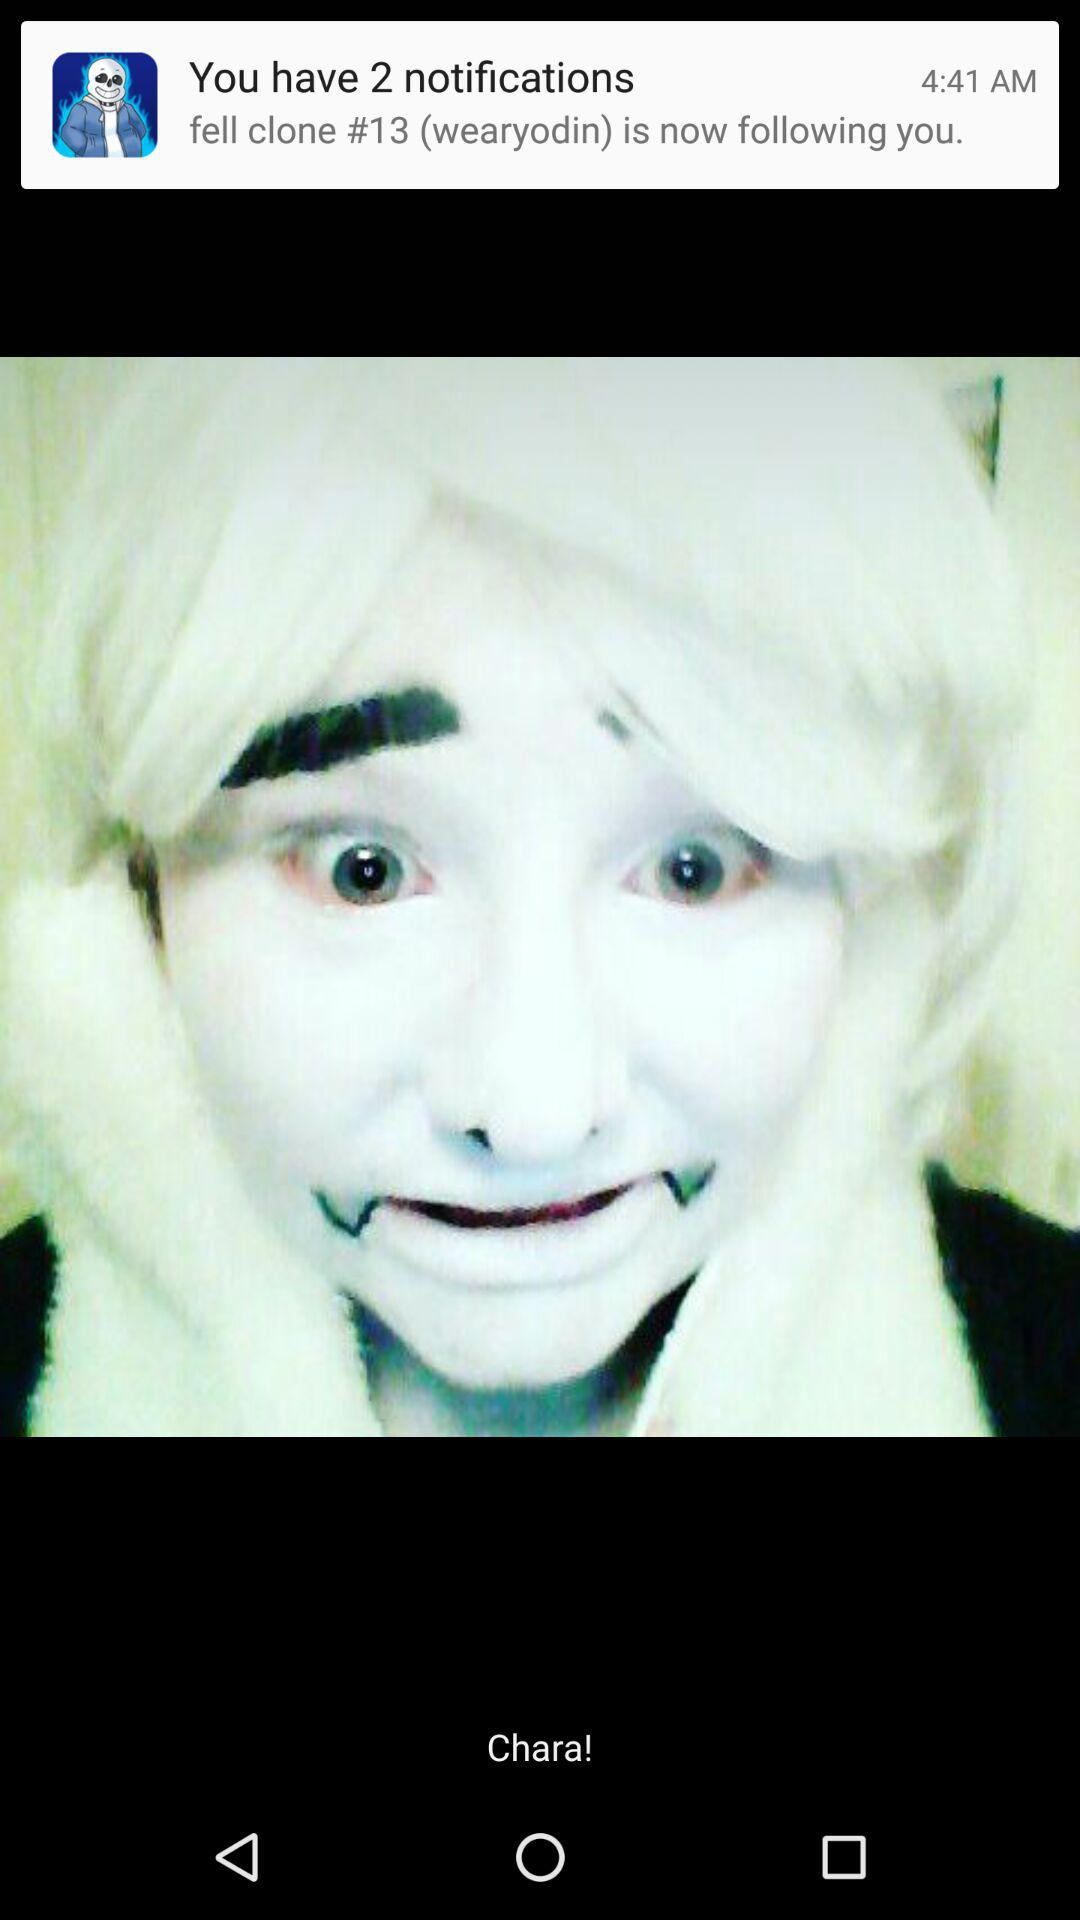At what time was the notification received? The notification was received at 4:41 AM. 